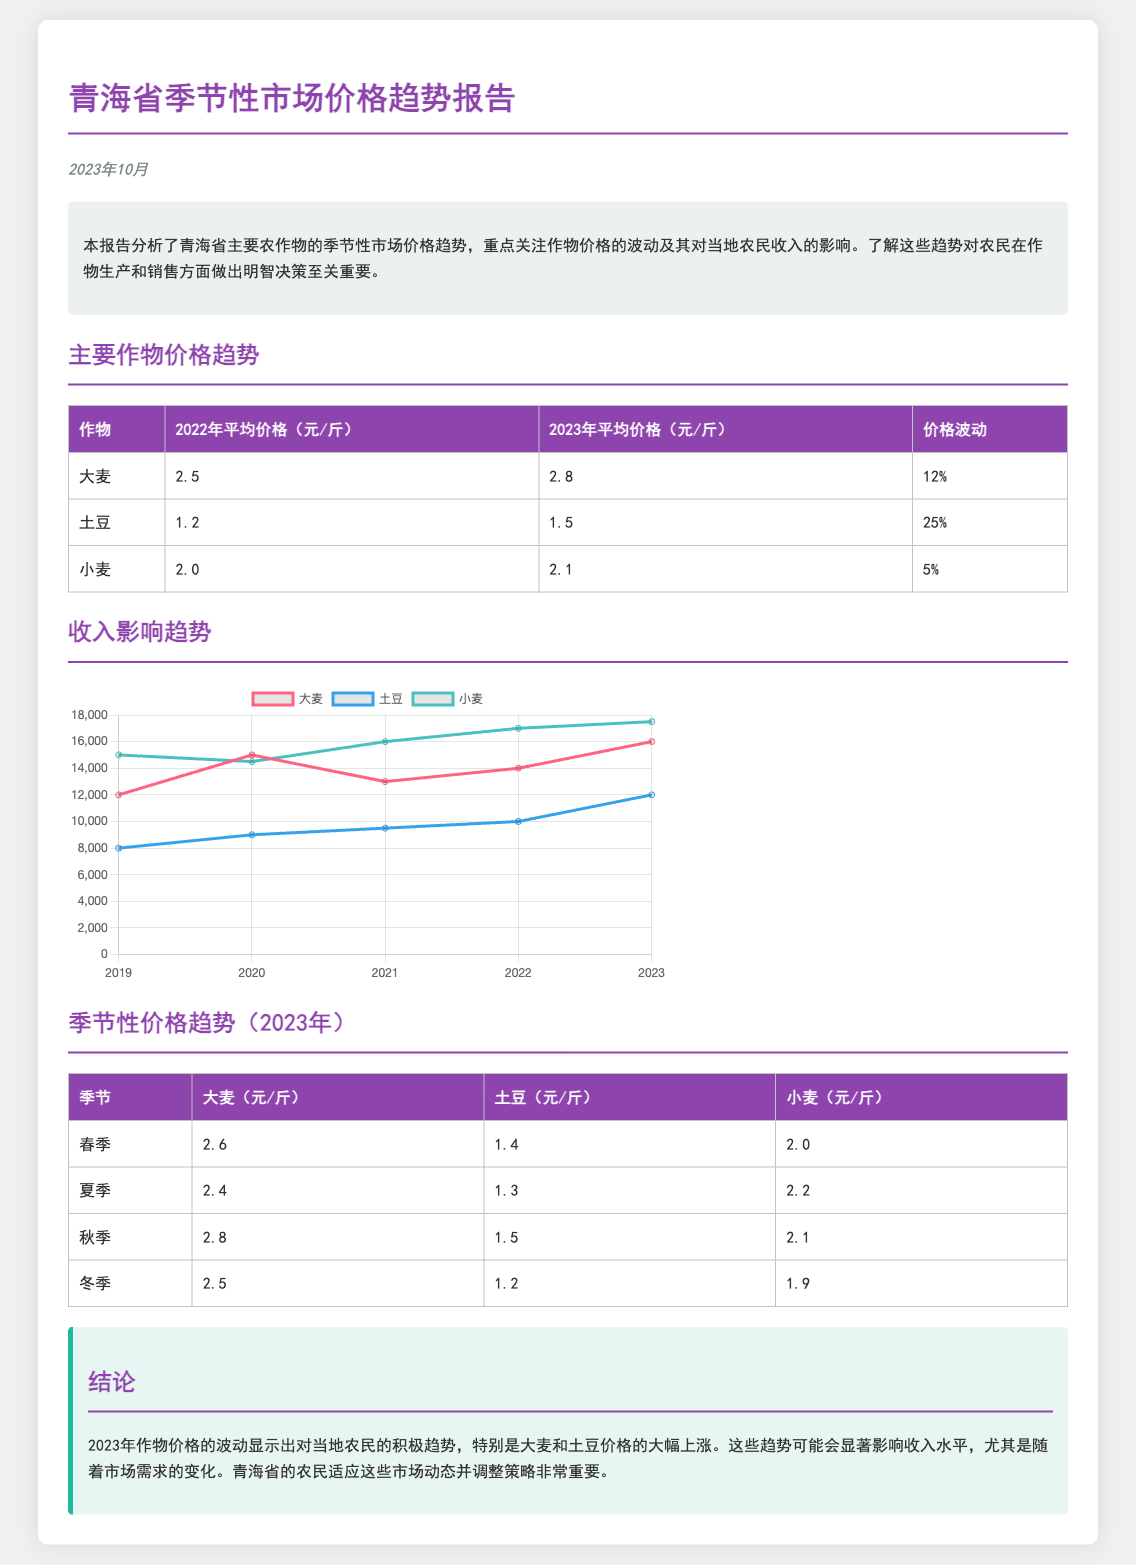What was the average price of potatoes in 2023? The document provides the average price of potatoes for 2023, which is 1.5 yuan per jin.
Answer: 1.5 yuan/斤 What percentage did the price of barley increase from 2022 to 2023? The price of barley increased from 2.5 yuan/斤 in 2022 to 2.8 yuan/斤 in 2023, representing a 12% increase.
Answer: 12% What was the highest seasonal price of wheat in 2023? The highest seasonal price of wheat in 2023 occurred in autumn, at 2.1 yuan per jin.
Answer: 2.1 yuan/斤 What was the total income for potatoes in 2023 based on the chart? According to the income trend chart, the total income for potatoes in 2023 was 12000 yuan.
Answer: 12000 yuan What crop experienced the largest price fluctuation from 2022 to 2023? A comparison of prices reveals that potatoes had the largest fluctuation with a 25% increase from 2022 to 2023.
Answer: Potatoes What is the main focus of this report? The report primarily focuses on analyzing seasonal market price trends of key crops and their impact on local farmers' income.
Answer: Crop price trends What year is the data presented for the income trend? The income trend data is shown from the years 2019 to 2023.
Answer: 2019 to 2023 What is the average price of wheat in 2022? The average price of wheat in 2022 was 2.0 yuan per jin.
Answer: 2.0 yuan/斤 What is the overall conclusion regarding the crop prices in 2023? The conclusion indicates a positive trend in crop prices in 2023, especially for barley and potatoes.
Answer: Positive trend 